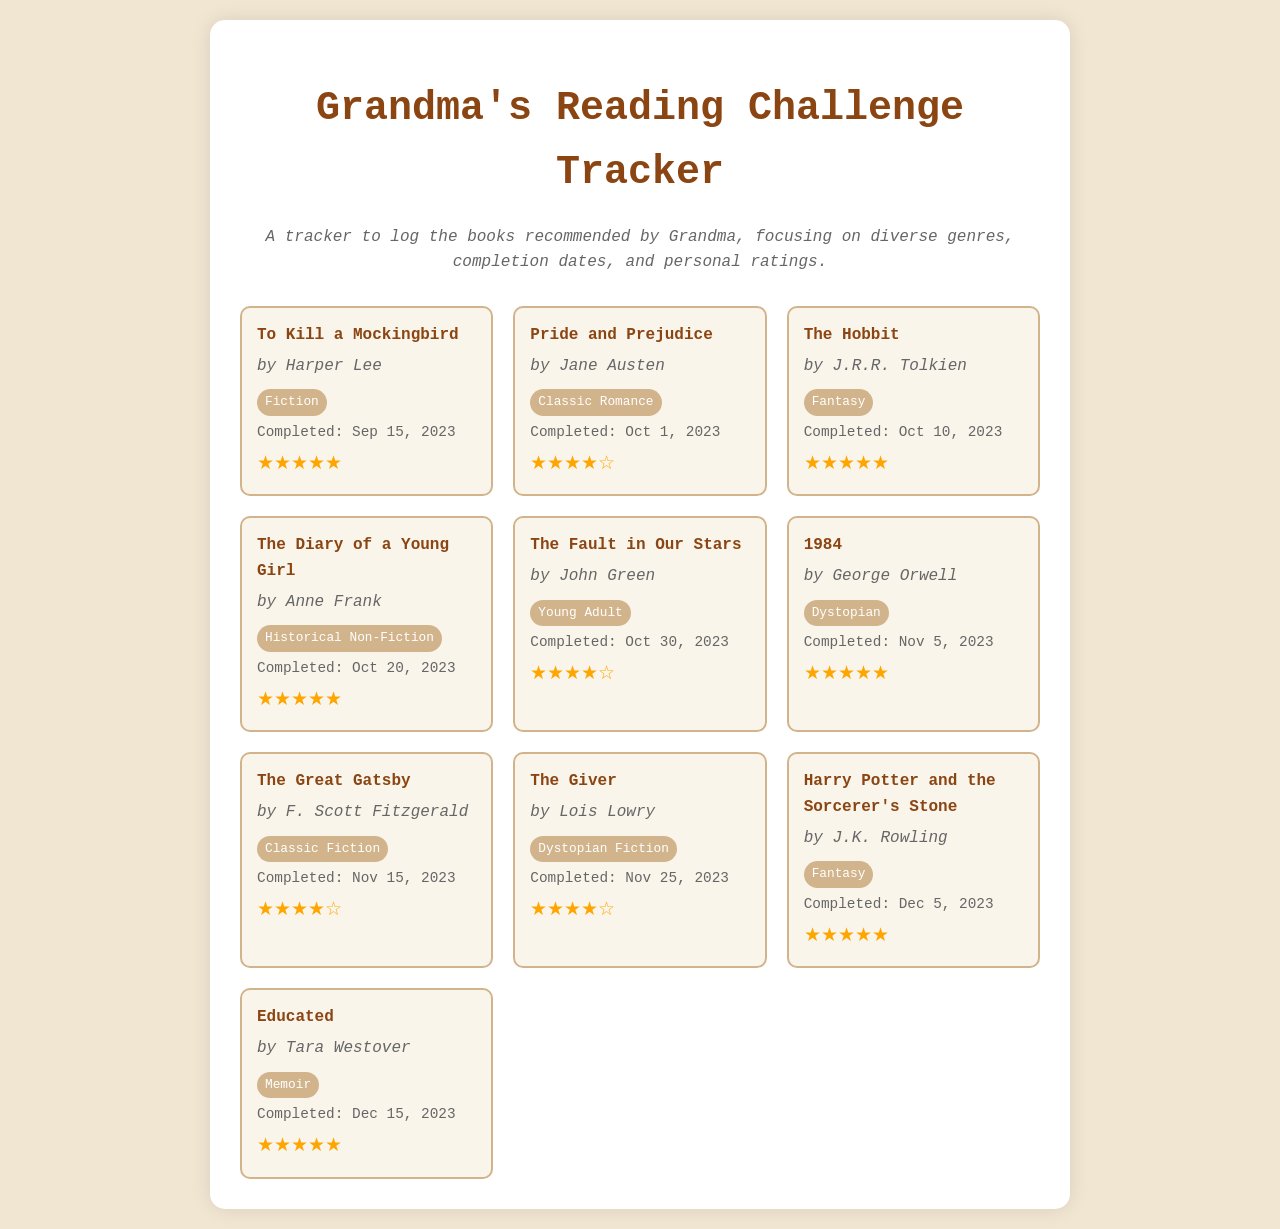What is the title of the first book? The first book listed in the tracker is "To Kill a Mockingbird."
Answer: To Kill a Mockingbird Who is the author of "Pride and Prejudice"? "Pride and Prejudice" is authored by Jane Austen.
Answer: Jane Austen How many books are completed in October 2023? There are four books completed in October 2023: "Pride and Prejudice," "The Hobbit," "The Fault in Our Stars," and "The Diary of a Young Girl."
Answer: 4 What genre is "The Great Gatsby"? "The Great Gatsby" falls under the genre of Classic Fiction.
Answer: Classic Fiction Which book received a rating of four stars? The books rated four stars are "Pride and Prejudice," "The Fault in Our Stars," "The Great Gatsby," and "The Giver."
Answer: Pride and Prejudice What date was "1984" completed? "1984" was completed on November 5, 2023.
Answer: Nov 5, 2023 Which genre is the most represented in the reading list? The genre represented the most is Fantasy, with two titles: "The Hobbit" and "Harry Potter and the Sorcerer's Stone."
Answer: Fantasy How many books in total are listed in the tracker? The tracker lists a total of ten books.
Answer: 10 What is the completion date of the last book? The last book, "Educated," was completed on December 15, 2023.
Answer: Dec 15, 2023 